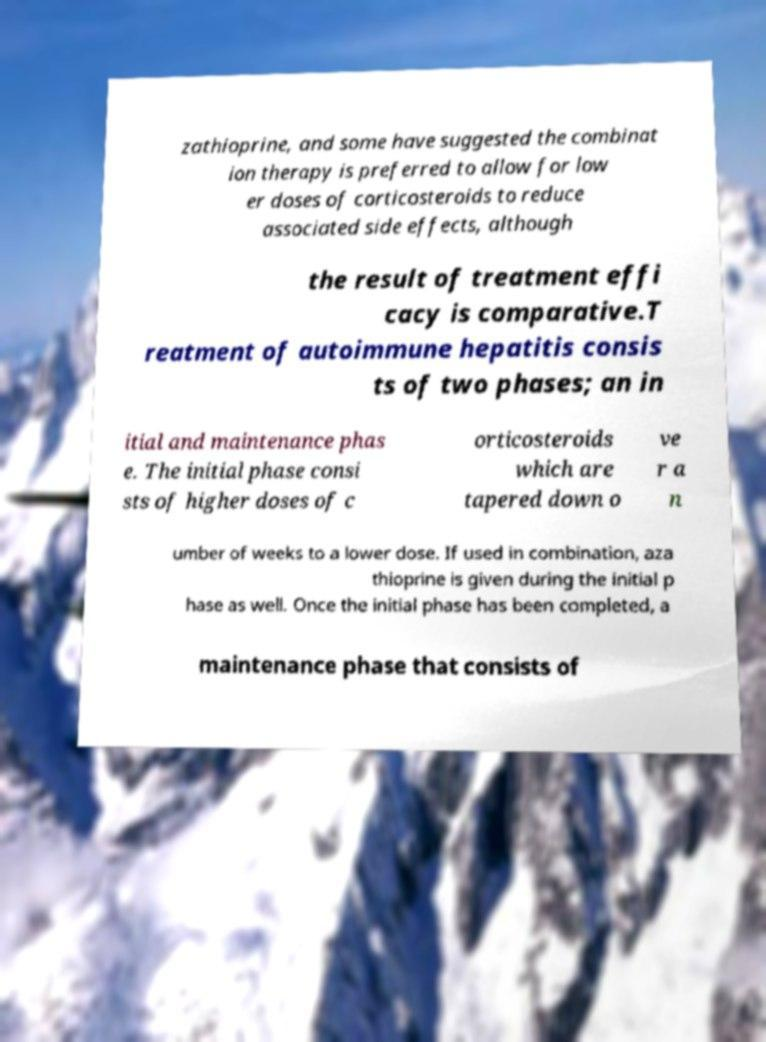For documentation purposes, I need the text within this image transcribed. Could you provide that? zathioprine, and some have suggested the combinat ion therapy is preferred to allow for low er doses of corticosteroids to reduce associated side effects, although the result of treatment effi cacy is comparative.T reatment of autoimmune hepatitis consis ts of two phases; an in itial and maintenance phas e. The initial phase consi sts of higher doses of c orticosteroids which are tapered down o ve r a n umber of weeks to a lower dose. If used in combination, aza thioprine is given during the initial p hase as well. Once the initial phase has been completed, a maintenance phase that consists of 